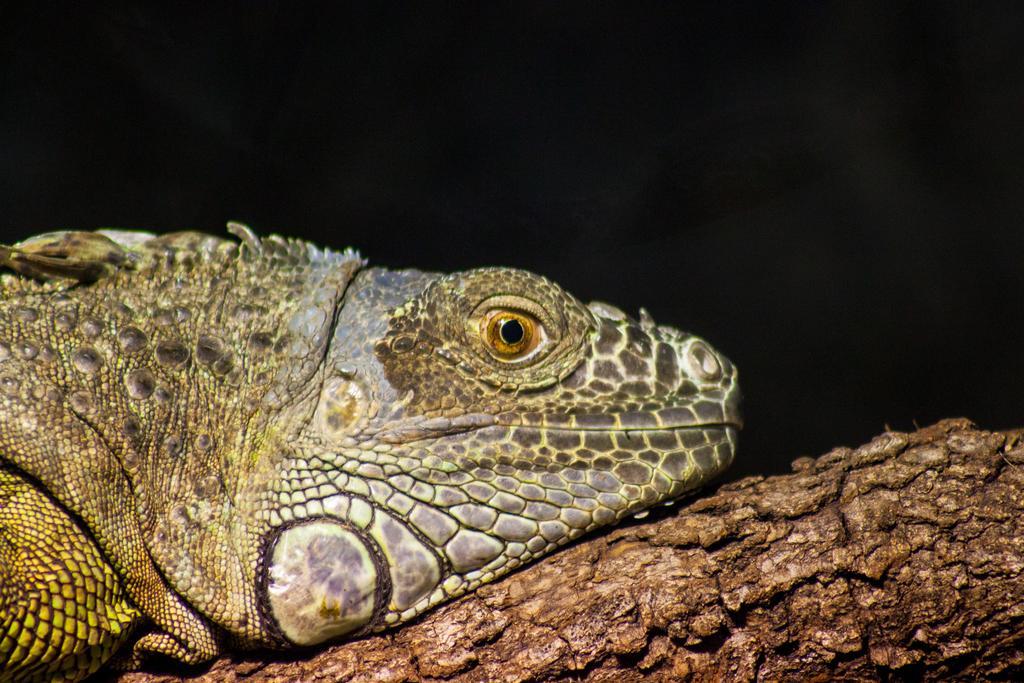Can you describe this image briefly? In this image there is a reptile on the wooden object, the background of the image is dark. 